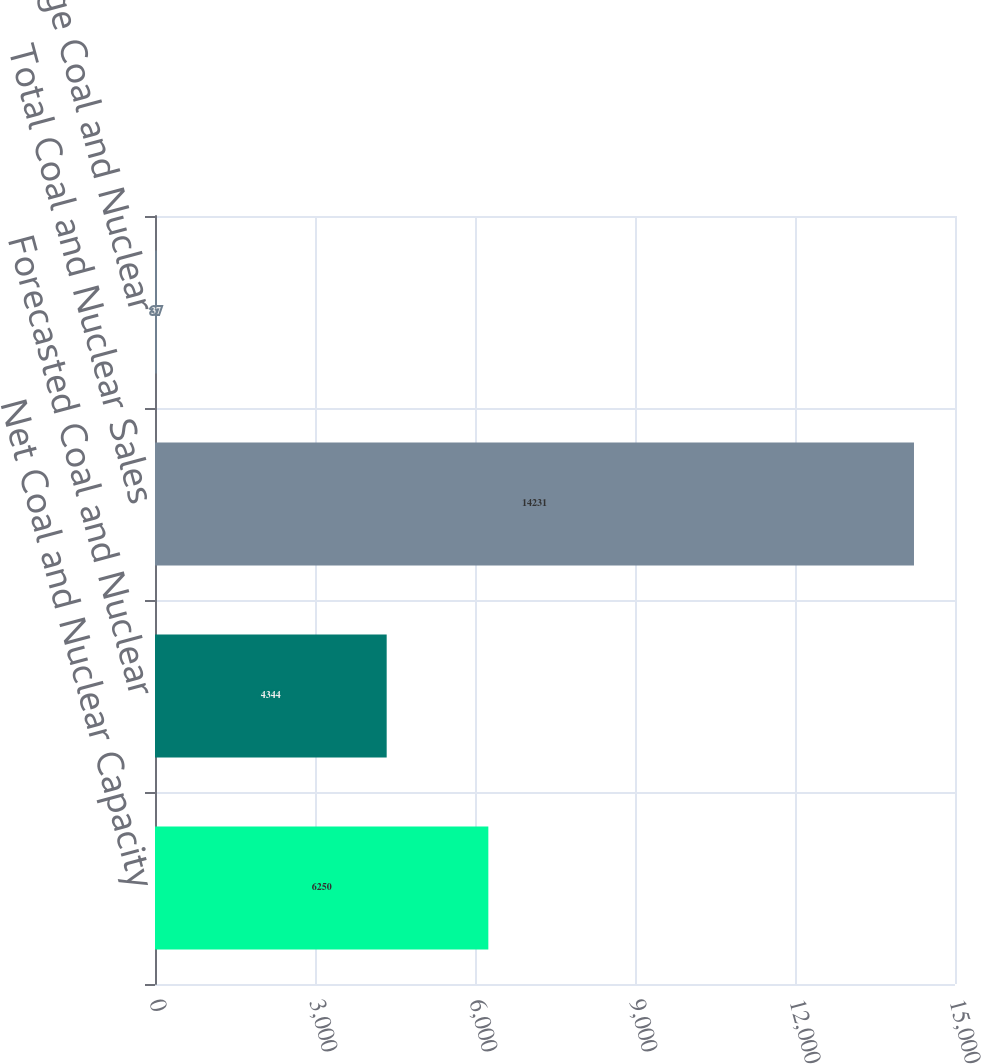<chart> <loc_0><loc_0><loc_500><loc_500><bar_chart><fcel>Net Coal and Nuclear Capacity<fcel>Forecasted Coal and Nuclear<fcel>Total Coal and Nuclear Sales<fcel>Percentage Coal and Nuclear<nl><fcel>6250<fcel>4344<fcel>14231<fcel>37<nl></chart> 